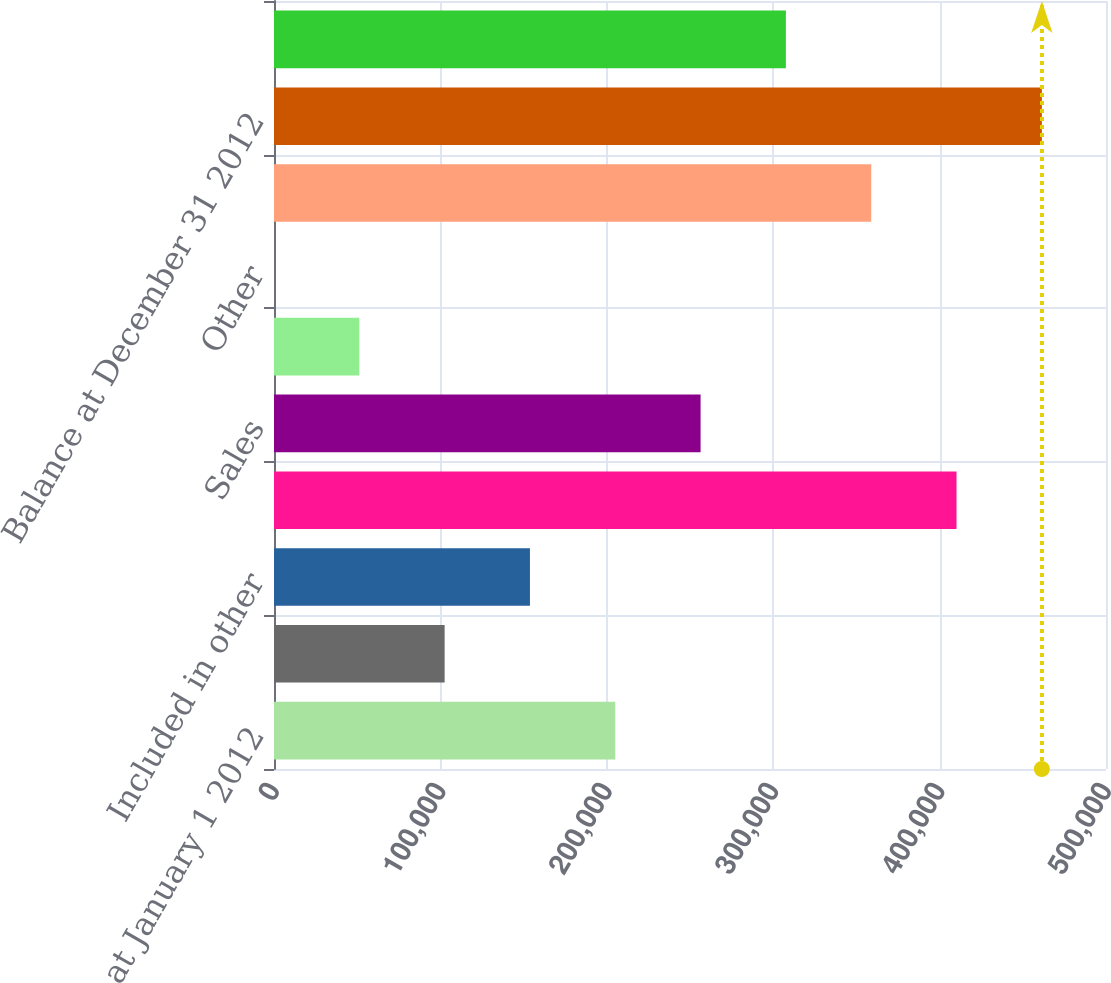Convert chart. <chart><loc_0><loc_0><loc_500><loc_500><bar_chart><fcel>Balance at January 1 2012<fcel>Included in realized<fcel>Included in other<fcel>Acquisitions<fcel>Sales<fcel>Amortization<fcel>Other<fcel>Transfers into Level 3<fcel>Balance at December 31 2012<fcel>Transfers out of Level 3<nl><fcel>205087<fcel>102545<fcel>153816<fcel>410172<fcel>256358<fcel>51273.6<fcel>2.47<fcel>358901<fcel>461443<fcel>307629<nl></chart> 